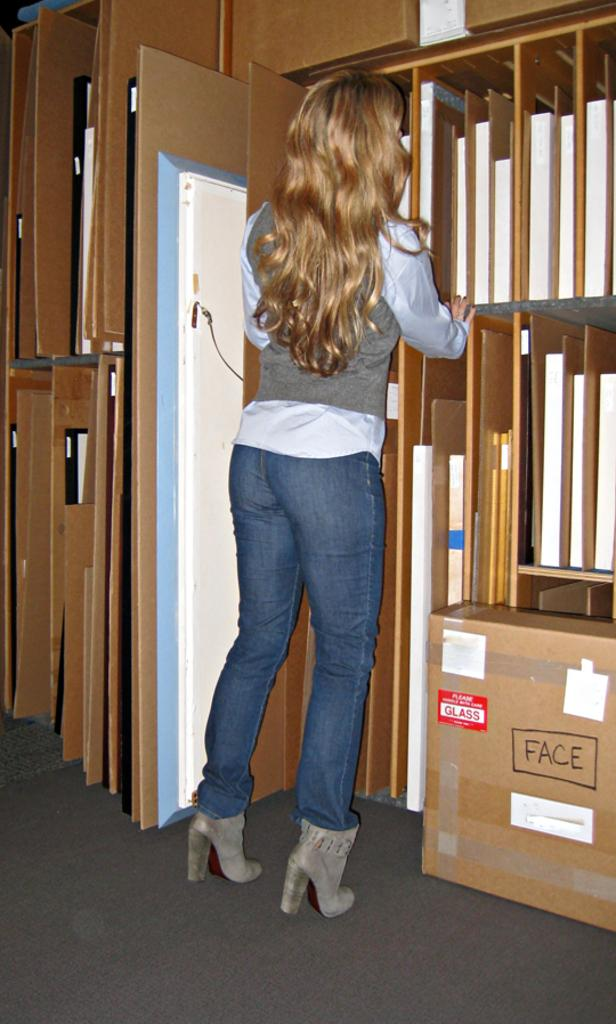<image>
Provide a brief description of the given image. The box labeled with "Face" contains glass items. 